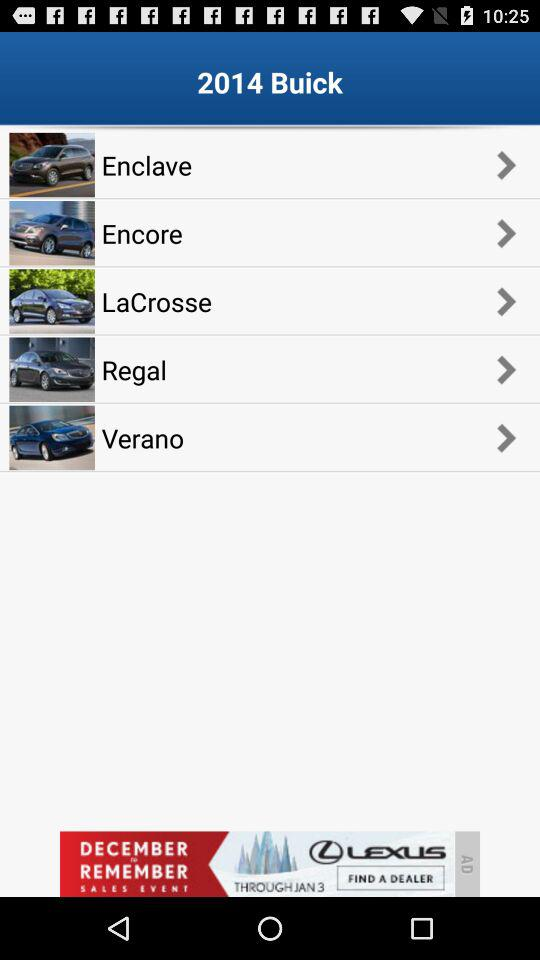How many models are there?
Answer the question using a single word or phrase. 5 